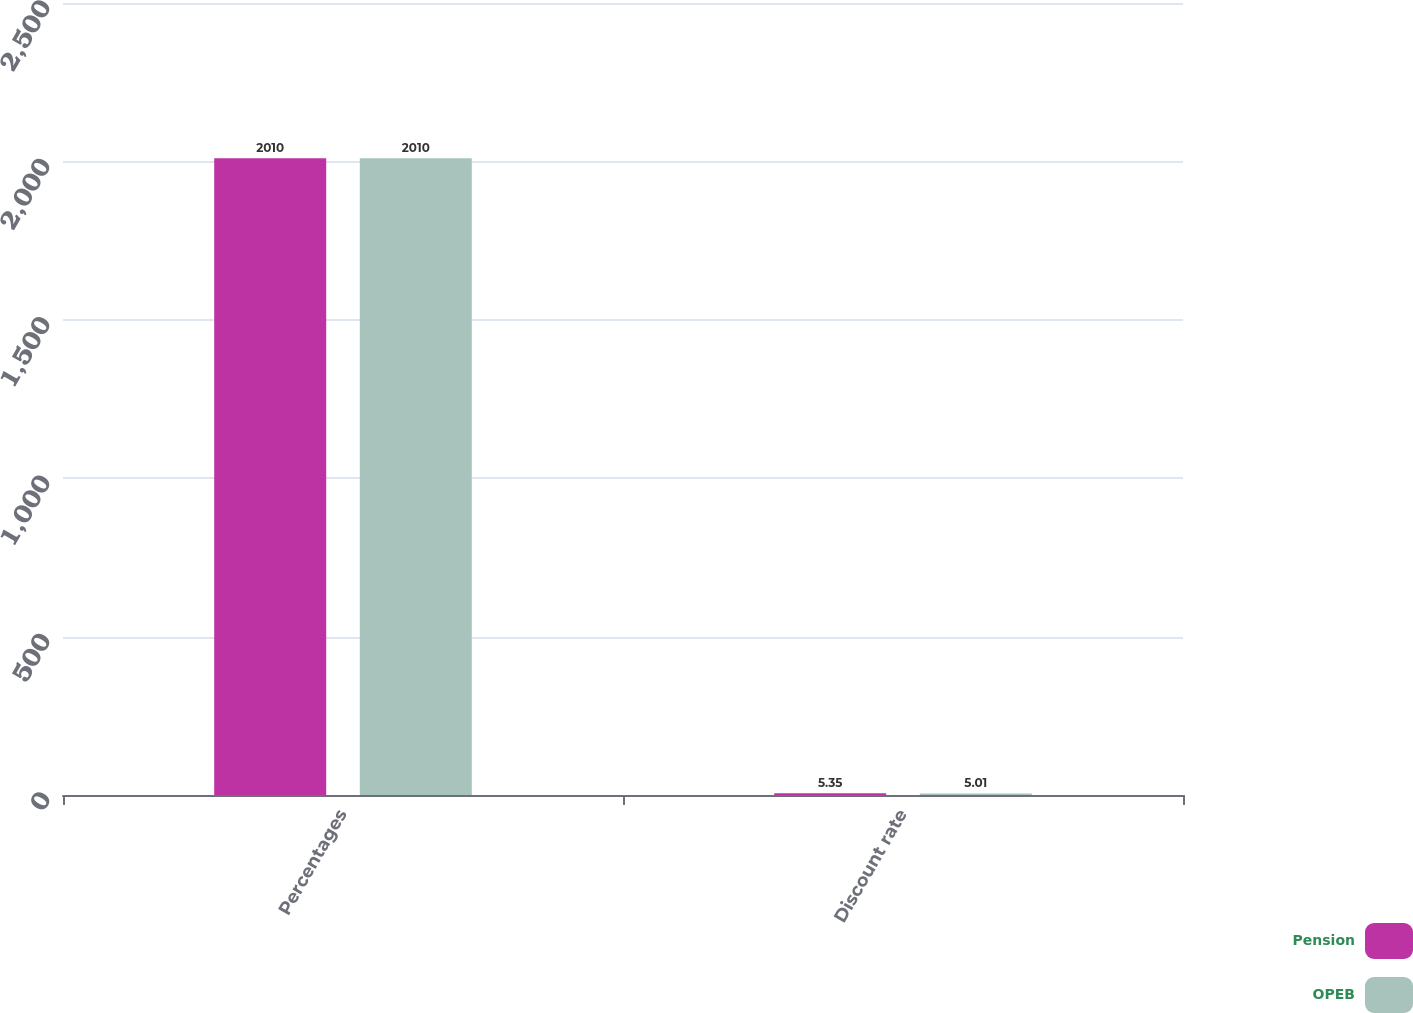Convert chart. <chart><loc_0><loc_0><loc_500><loc_500><stacked_bar_chart><ecel><fcel>Percentages<fcel>Discount rate<nl><fcel>Pension<fcel>2010<fcel>5.35<nl><fcel>OPEB<fcel>2010<fcel>5.01<nl></chart> 